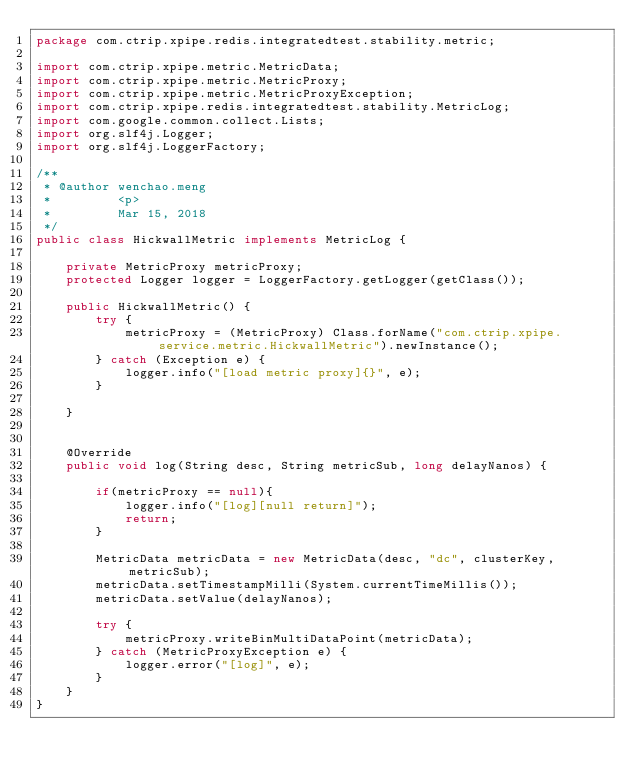Convert code to text. <code><loc_0><loc_0><loc_500><loc_500><_Java_>package com.ctrip.xpipe.redis.integratedtest.stability.metric;

import com.ctrip.xpipe.metric.MetricData;
import com.ctrip.xpipe.metric.MetricProxy;
import com.ctrip.xpipe.metric.MetricProxyException;
import com.ctrip.xpipe.redis.integratedtest.stability.MetricLog;
import com.google.common.collect.Lists;
import org.slf4j.Logger;
import org.slf4j.LoggerFactory;

/**
 * @author wenchao.meng
 *         <p>
 *         Mar 15, 2018
 */
public class HickwallMetric implements MetricLog {

    private MetricProxy metricProxy;
    protected Logger logger = LoggerFactory.getLogger(getClass());

    public HickwallMetric() {
        try {
            metricProxy = (MetricProxy) Class.forName("com.ctrip.xpipe.service.metric.HickwallMetric").newInstance();
        } catch (Exception e) {
            logger.info("[load metric proxy]{}", e);
        }

    }


    @Override
    public void log(String desc, String metricSub, long delayNanos) {

        if(metricProxy == null){
            logger.info("[log][null return]");
            return;
        }

        MetricData metricData = new MetricData(desc, "dc", clusterKey, metricSub);
        metricData.setTimestampMilli(System.currentTimeMillis());
        metricData.setValue(delayNanos);

        try {
            metricProxy.writeBinMultiDataPoint(metricData);
        } catch (MetricProxyException e) {
            logger.error("[log]", e);
        }
    }
}
</code> 